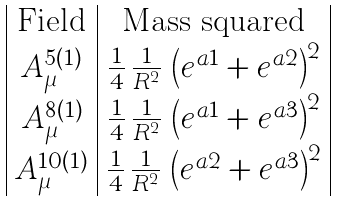<formula> <loc_0><loc_0><loc_500><loc_500>\begin{array} { | c | c | } \text {Field} & \text {Mass squared} \\ A ^ { 5 ( 1 ) } _ { \mu } & \frac { 1 } { 4 } \, \frac { 1 } { R ^ { 2 } } \, \left ( e ^ { a 1 } + e ^ { a 2 } \right ) ^ { 2 } \\ A ^ { 8 ( 1 ) } _ { \mu } & \frac { 1 } { 4 } \, \frac { 1 } { R ^ { 2 } } \, \left ( e ^ { a 1 } + e ^ { a 3 } \right ) ^ { 2 } \\ A ^ { 1 0 ( 1 ) } _ { \mu } & \frac { 1 } { 4 } \, \frac { 1 } { R ^ { 2 } } \, \left ( e ^ { a 2 } + e ^ { a 3 } \right ) ^ { 2 } \\ \end{array}</formula> 